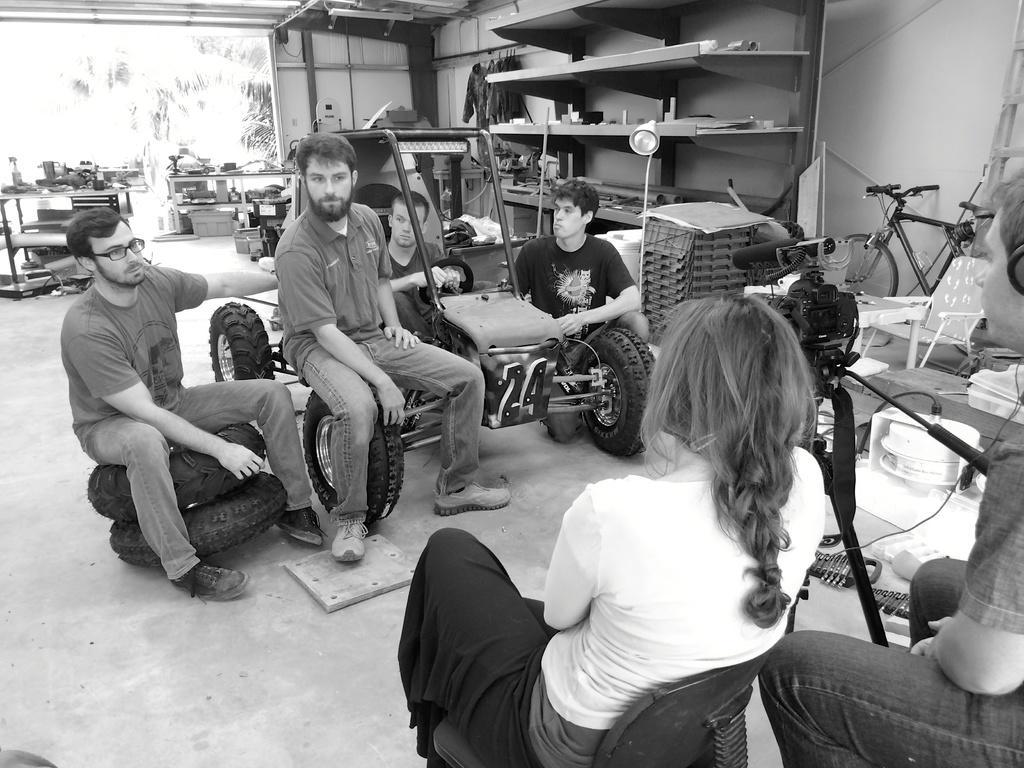Can you describe this image briefly? This is a black and white image. People are sitting in a room. A person is sitting inside a vehicle. 2 people are sitting on the tyres. Behind them there are shelves and there are chairs and a bicycle at the right. 